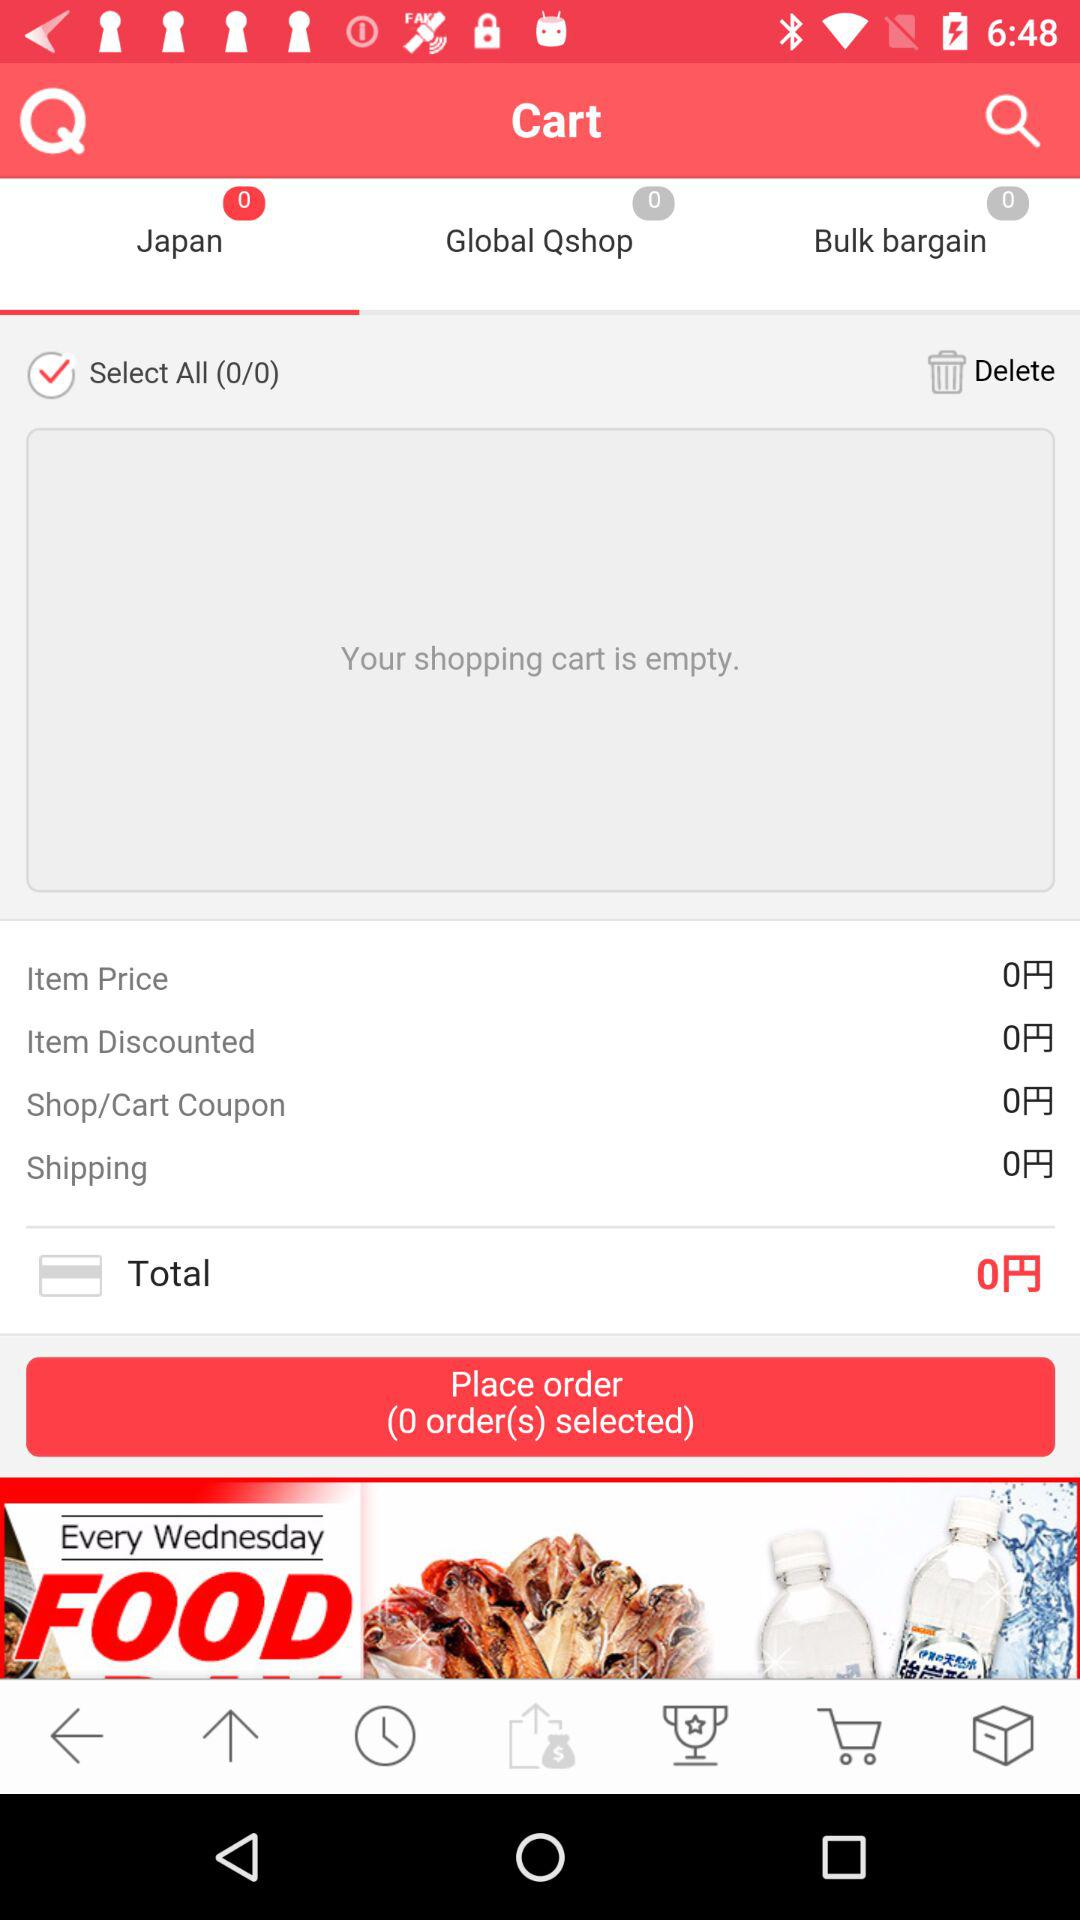How many items are in my cart?
Answer the question using a single word or phrase. 0 